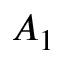Convert formula to latex. <formula><loc_0><loc_0><loc_500><loc_500>A _ { 1 }</formula> 